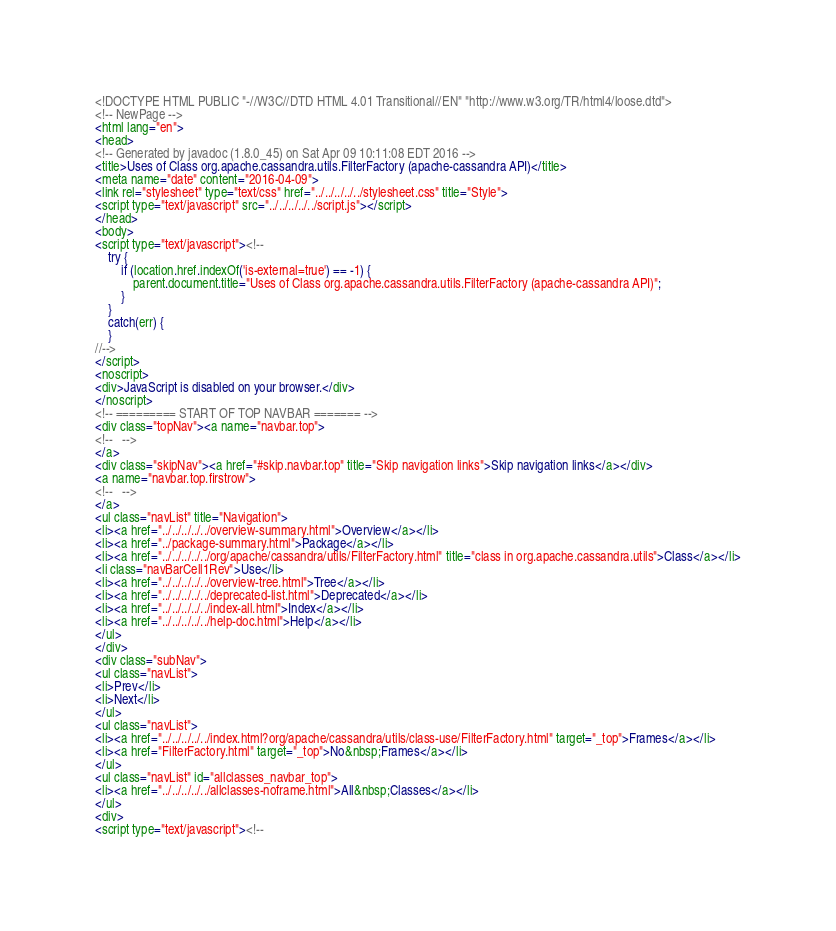Convert code to text. <code><loc_0><loc_0><loc_500><loc_500><_HTML_><!DOCTYPE HTML PUBLIC "-//W3C//DTD HTML 4.01 Transitional//EN" "http://www.w3.org/TR/html4/loose.dtd">
<!-- NewPage -->
<html lang="en">
<head>
<!-- Generated by javadoc (1.8.0_45) on Sat Apr 09 10:11:08 EDT 2016 -->
<title>Uses of Class org.apache.cassandra.utils.FilterFactory (apache-cassandra API)</title>
<meta name="date" content="2016-04-09">
<link rel="stylesheet" type="text/css" href="../../../../../stylesheet.css" title="Style">
<script type="text/javascript" src="../../../../../script.js"></script>
</head>
<body>
<script type="text/javascript"><!--
    try {
        if (location.href.indexOf('is-external=true') == -1) {
            parent.document.title="Uses of Class org.apache.cassandra.utils.FilterFactory (apache-cassandra API)";
        }
    }
    catch(err) {
    }
//-->
</script>
<noscript>
<div>JavaScript is disabled on your browser.</div>
</noscript>
<!-- ========= START OF TOP NAVBAR ======= -->
<div class="topNav"><a name="navbar.top">
<!--   -->
</a>
<div class="skipNav"><a href="#skip.navbar.top" title="Skip navigation links">Skip navigation links</a></div>
<a name="navbar.top.firstrow">
<!--   -->
</a>
<ul class="navList" title="Navigation">
<li><a href="../../../../../overview-summary.html">Overview</a></li>
<li><a href="../package-summary.html">Package</a></li>
<li><a href="../../../../../org/apache/cassandra/utils/FilterFactory.html" title="class in org.apache.cassandra.utils">Class</a></li>
<li class="navBarCell1Rev">Use</li>
<li><a href="../../../../../overview-tree.html">Tree</a></li>
<li><a href="../../../../../deprecated-list.html">Deprecated</a></li>
<li><a href="../../../../../index-all.html">Index</a></li>
<li><a href="../../../../../help-doc.html">Help</a></li>
</ul>
</div>
<div class="subNav">
<ul class="navList">
<li>Prev</li>
<li>Next</li>
</ul>
<ul class="navList">
<li><a href="../../../../../index.html?org/apache/cassandra/utils/class-use/FilterFactory.html" target="_top">Frames</a></li>
<li><a href="FilterFactory.html" target="_top">No&nbsp;Frames</a></li>
</ul>
<ul class="navList" id="allclasses_navbar_top">
<li><a href="../../../../../allclasses-noframe.html">All&nbsp;Classes</a></li>
</ul>
<div>
<script type="text/javascript"><!--</code> 